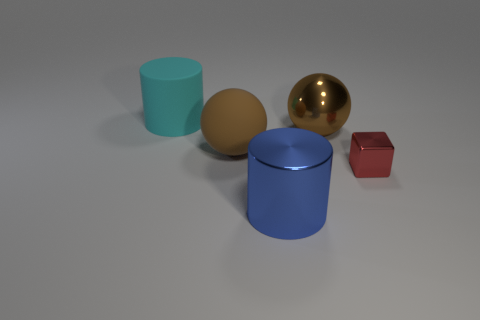Add 3 cyan rubber cylinders. How many objects exist? 8 Subtract 0 brown cubes. How many objects are left? 5 Subtract all cubes. How many objects are left? 4 Subtract 1 blocks. How many blocks are left? 0 Subtract all gray spheres. Subtract all gray cylinders. How many spheres are left? 2 Subtract all red spheres. How many cyan cylinders are left? 1 Subtract all large objects. Subtract all big brown matte objects. How many objects are left? 0 Add 1 blue metallic cylinders. How many blue metallic cylinders are left? 2 Add 3 tiny metal cubes. How many tiny metal cubes exist? 4 